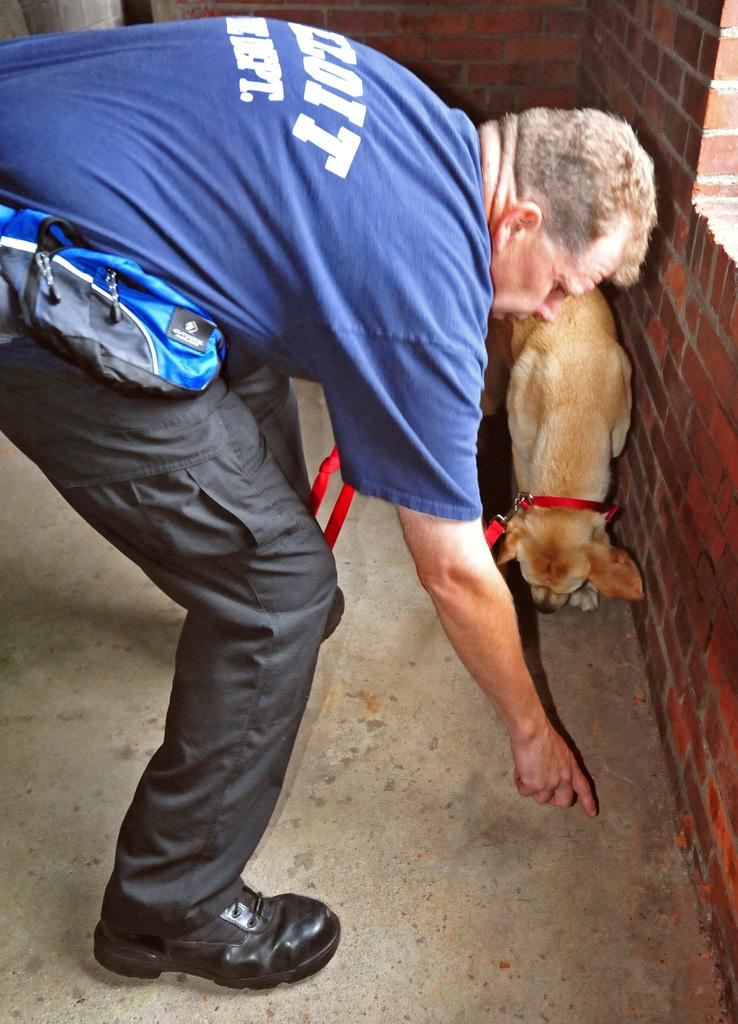What is the main subject in the middle of the image? There is a man standing in the middle of the image. What can be seen in front of the man? There is a dog in front of the man. What is located behind the dog? There is a wall behind the dog. What type of flowers can be seen around the man's neck in the image? There are no flowers visible around the man's neck in the image. Is the man driving a vehicle in the image? There is no vehicle present in the image, and the man is not driving. 